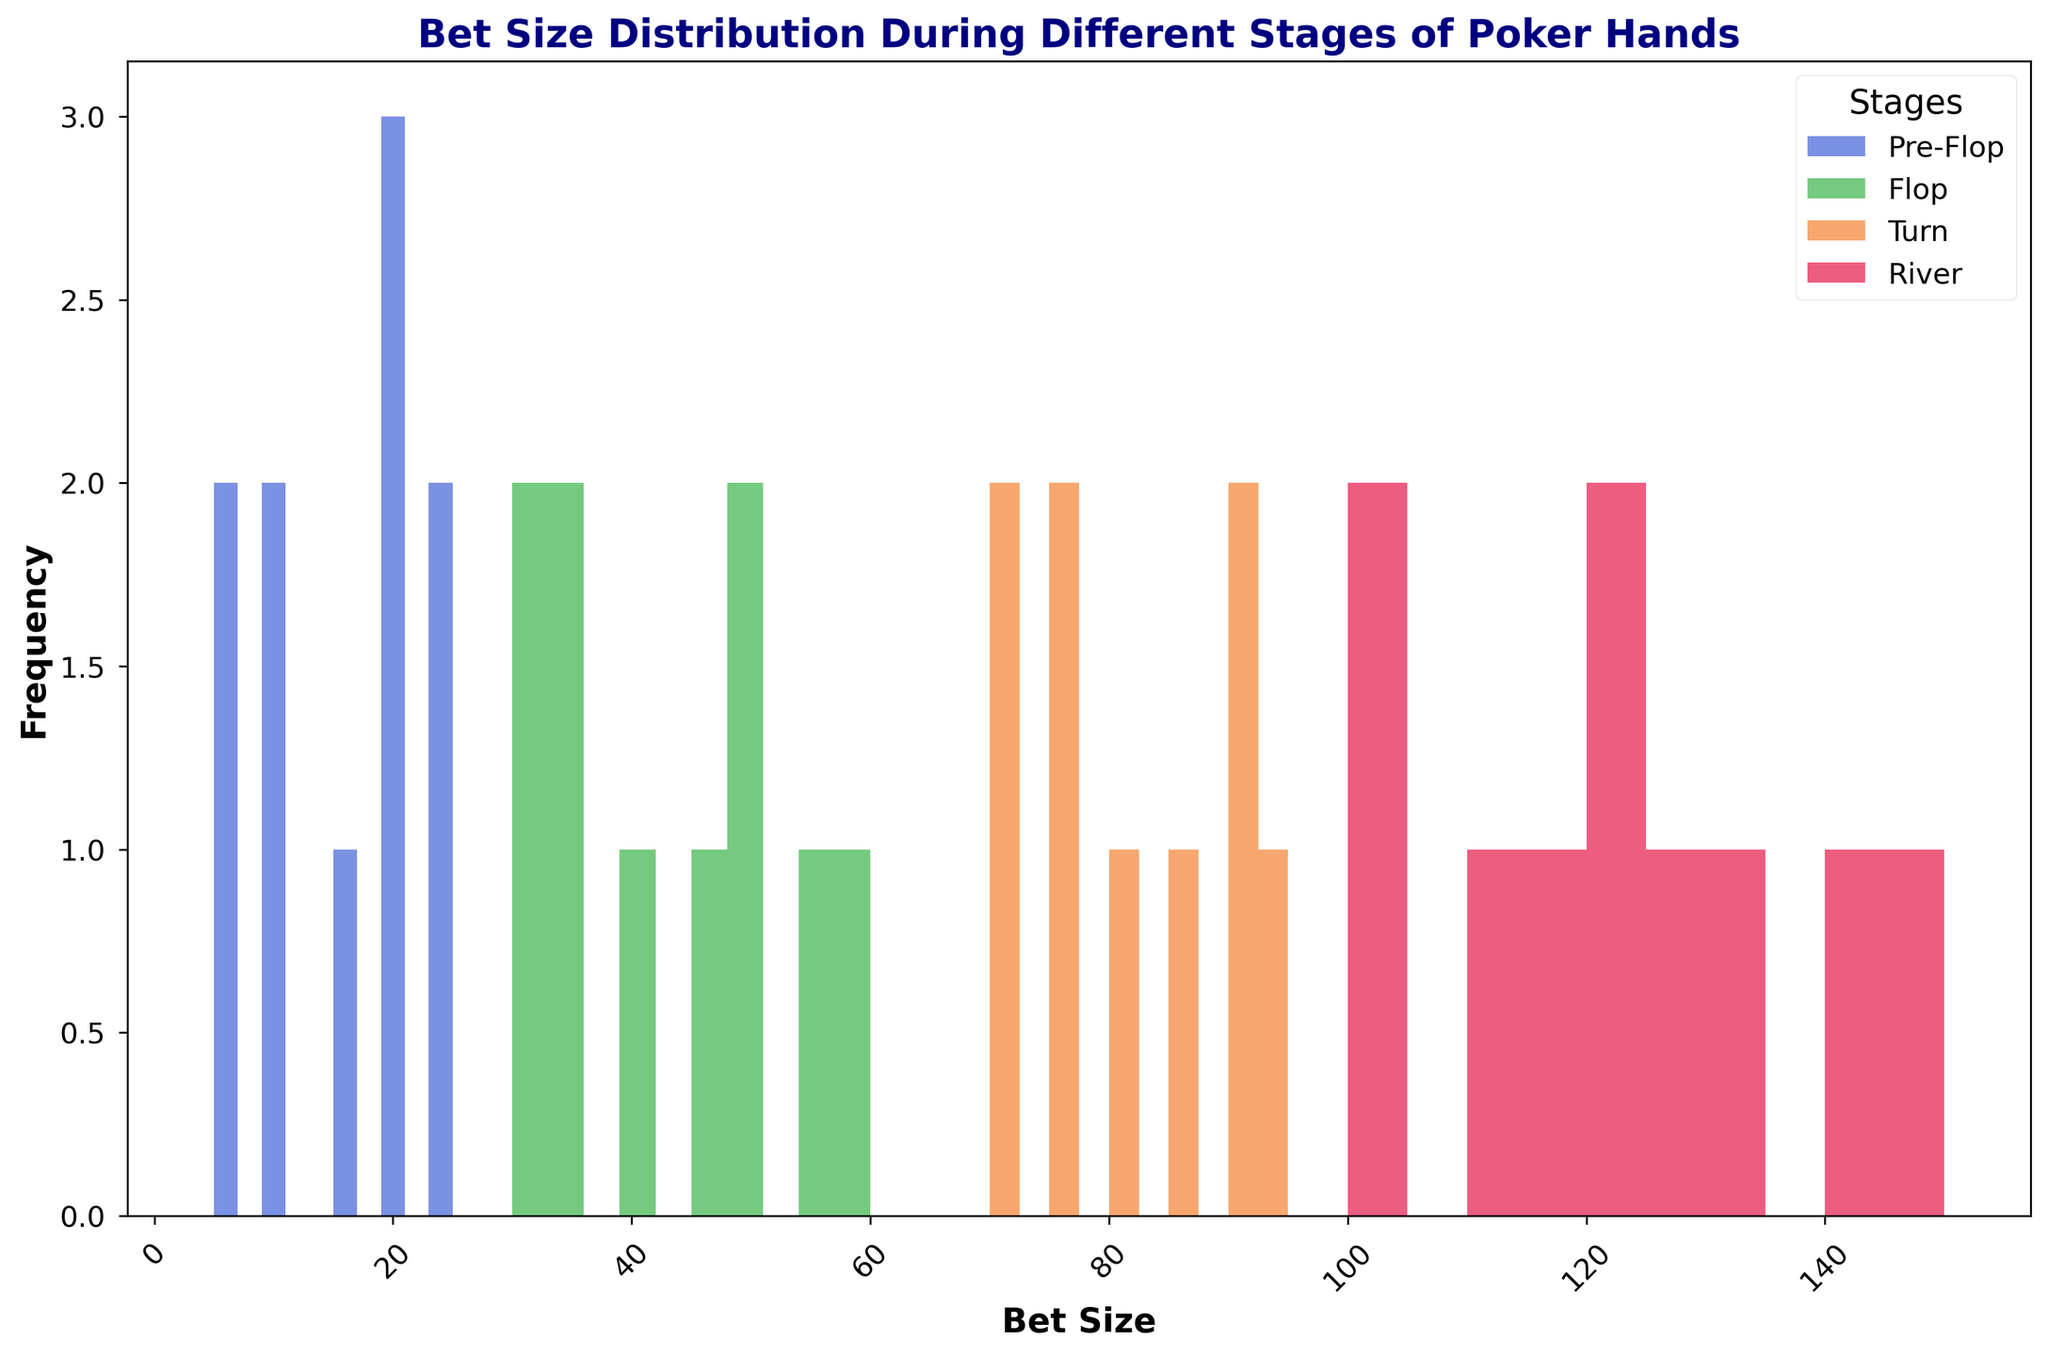what is the most frequent bet size during the Pre-Flop stage? Observe the heights of the bars in the histogram for the Pre-Flop stage. The tallest bar indicates the most frequent bet size.
Answer: 20 Between the Flop and the Turn stages, which one has a wider range of bet sizes? Look at the span of the bars from the lowest to the highest bet size for both stages. The wider the span, the larger the range of bet sizes.
Answer: Turn Is the frequency of any bet size the same between the River and Turn stages? Compare the heights of the bars in the histogram for both the River and Turn stages to see if any bet sizes have bars of the same height.
Answer: No What is the highest bet size observed in the River stage? Check the rightmost bar in the histogram for the River stage. The bet size at this bar represents the highest bet size.
Answer: 150 Does the Flop stage have any bet sizes that appear more frequently than 50? Observe the heights of all bars in the histogram for the Flop stage. If any bar is taller than the one at 50, it indicates a bet size more frequent than 50.
Answer: No Which stage has the most uniform distribution of bet sizes? Look for the stage where the heights of the bars are most even. Uniform distribution means the bars should be close in height.
Answer: Pre-Flop By how much does the most frequent bet size in the Pre-Flop stage differ from the most frequent bet size in the River stage? Find the most frequent bet sizes for both Pre-Flop and River stages by identifying the tallest bars. Subtract the Pre-Flop value from the River value.
Answer: 130 In the Turn stage, are there more bets in the range of 70-80 or in the range of 85-95? Count the number of bars and their heights in the ranges 70-80 and 85-95 in the Turn stage histogram. Compare the sums of the bar heights in both ranges.
Answer: 85-95 